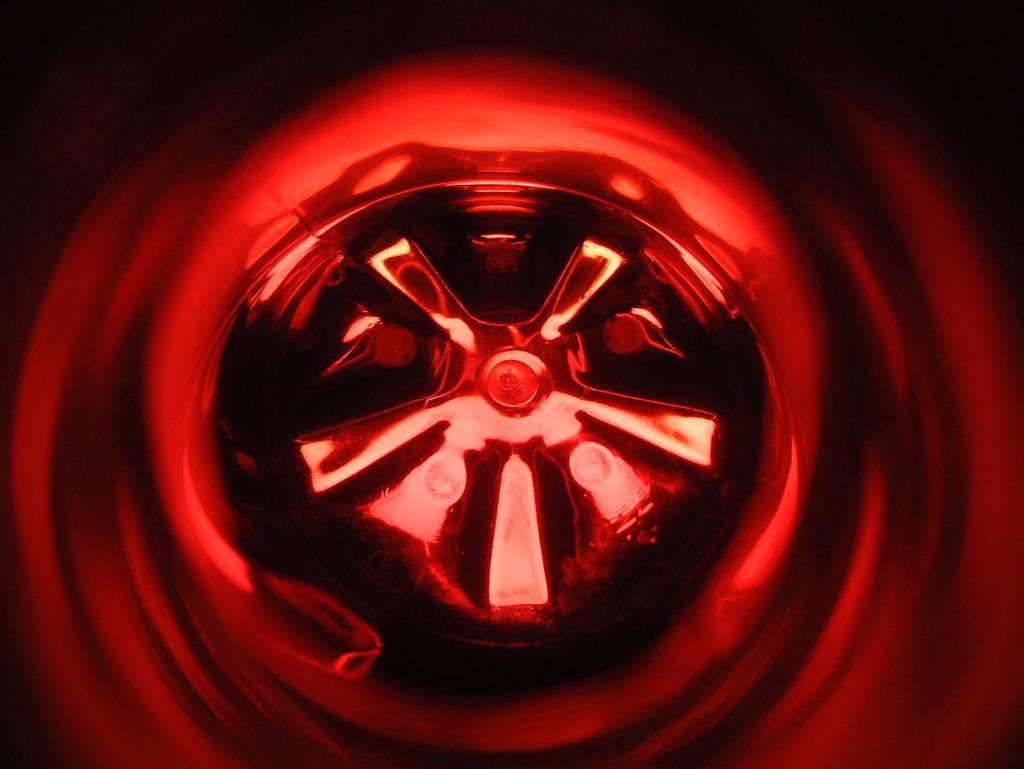Can you describe this image briefly? This is an animated image. In the middle there is a wheel and around it there is a red color lighting. 